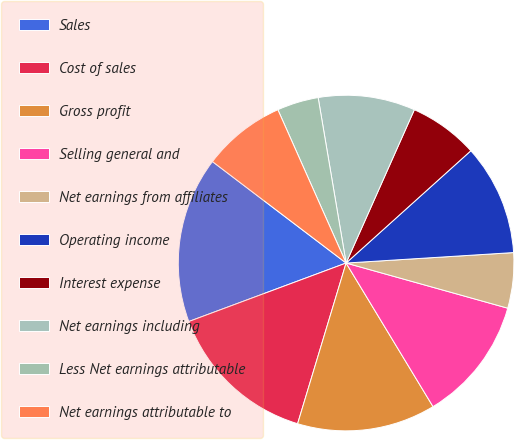Convert chart. <chart><loc_0><loc_0><loc_500><loc_500><pie_chart><fcel>Sales<fcel>Cost of sales<fcel>Gross profit<fcel>Selling general and<fcel>Net earnings from affiliates<fcel>Operating income<fcel>Interest expense<fcel>Net earnings including<fcel>Less Net earnings attributable<fcel>Net earnings attributable to<nl><fcel>16.0%<fcel>14.67%<fcel>13.33%<fcel>12.0%<fcel>5.33%<fcel>10.67%<fcel>6.67%<fcel>9.33%<fcel>4.0%<fcel>8.0%<nl></chart> 